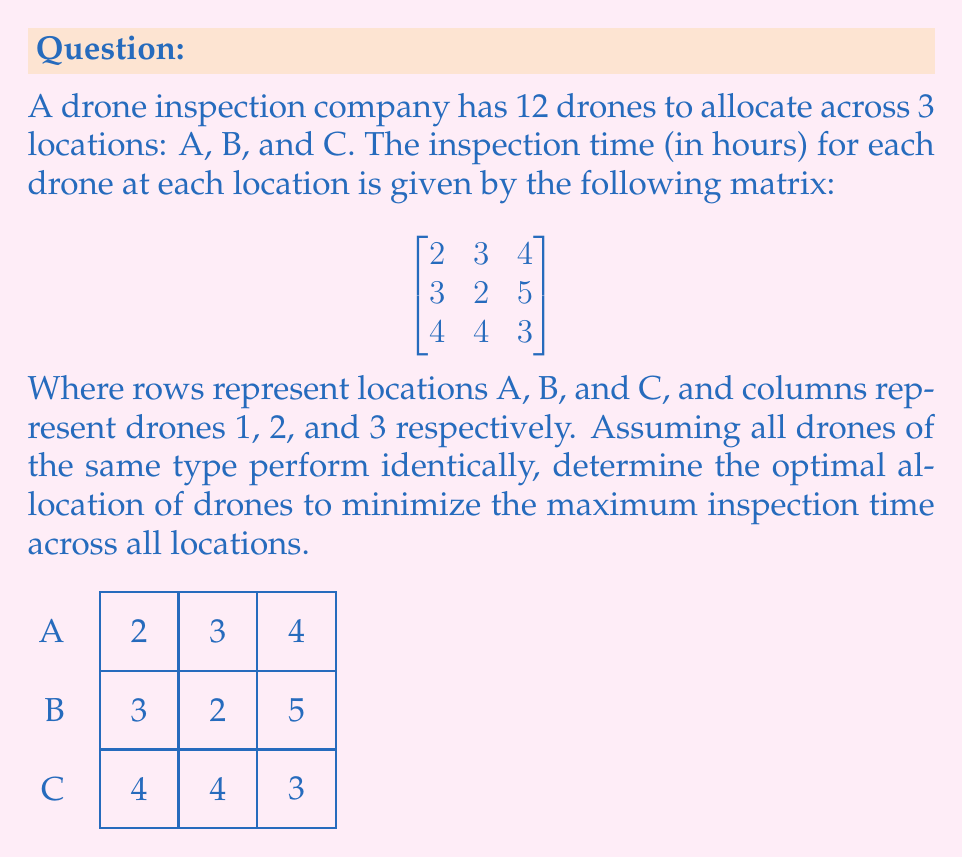Help me with this question. To solve this problem, we need to follow these steps:

1) First, we need to understand that the goal is to minimize the maximum inspection time across all locations. This means we want to distribute the drones in a way that makes the inspection times as balanced as possible.

2) We have 12 drones in total, and 3 types of drones. Let's denote the number of each type as $x$, $y$, and $z$ respectively. So:

   $x + y + z = 12$

3) The inspection time for each location will be:
   Location A: $2x + 3y + 4z$
   Location B: $3x + 2y + 5z$
   Location C: $4x + 4y + 3z$

4) We want to minimize the maximum of these three expressions. Let's call this maximum $M$. So:

   $M = \max(2x + 3y + 4z, 3x + 2y + 5z, 4x + 4y + 3z)$

5) To minimize $M$, ideally, we want all three expressions to be equal. If they're not equal, we can always improve by moving drones from the location with the lowest time to the one with the highest.

6) So, let's set them equal:

   $2x + 3y + 4z = 3x + 2y + 5z = 4x + 4y + 3z$

7) From the first two equations:
   $2x + 3y + 4z = 3x + 2y + 5z$
   $-x + y - z = 0$
   $x = y - z$

8) Substituting this into $x + y + z = 12$:
   $(y - z) + y + z = 12$
   $2y = 12$
   $y = 6$

9) Now we have $y = 6$ and $x = 6 - z$. Substituting into $x + y + z = 12$:
   $(6 - z) + 6 + z = 12$
   $12 = 12$

   This confirms our solution is consistent.

10) To find $z$, we can use the equality of the first and third expressions:
    $2(6-z) + 3(6) + 4z = 4(6-z) + 4(6) + 3z$
    $12 - 2z + 18 + 4z = 24 - 4z + 24 + 3z$
    $30 + 2z = 48 - z$
    $3z = 18$
    $z = 6$

11) Therefore, the optimal allocation is:
    $x = 0$ (drones of type 1)
    $y = 6$ (drones of type 2)
    $z = 6$ (drones of type 3)

12) We can verify that this gives equal inspection times for all locations:
    Location A: $2(0) + 3(6) + 4(6) = 42$
    Location B: $3(0) + 2(6) + 5(6) = 42$
    Location C: $4(0) + 4(6) + 3(6) = 42$

Thus, the minimum maximum inspection time is 42 hours.
Answer: 0 drones of type 1, 6 drones of type 2, 6 drones of type 3; minimum maximum inspection time: 42 hours 